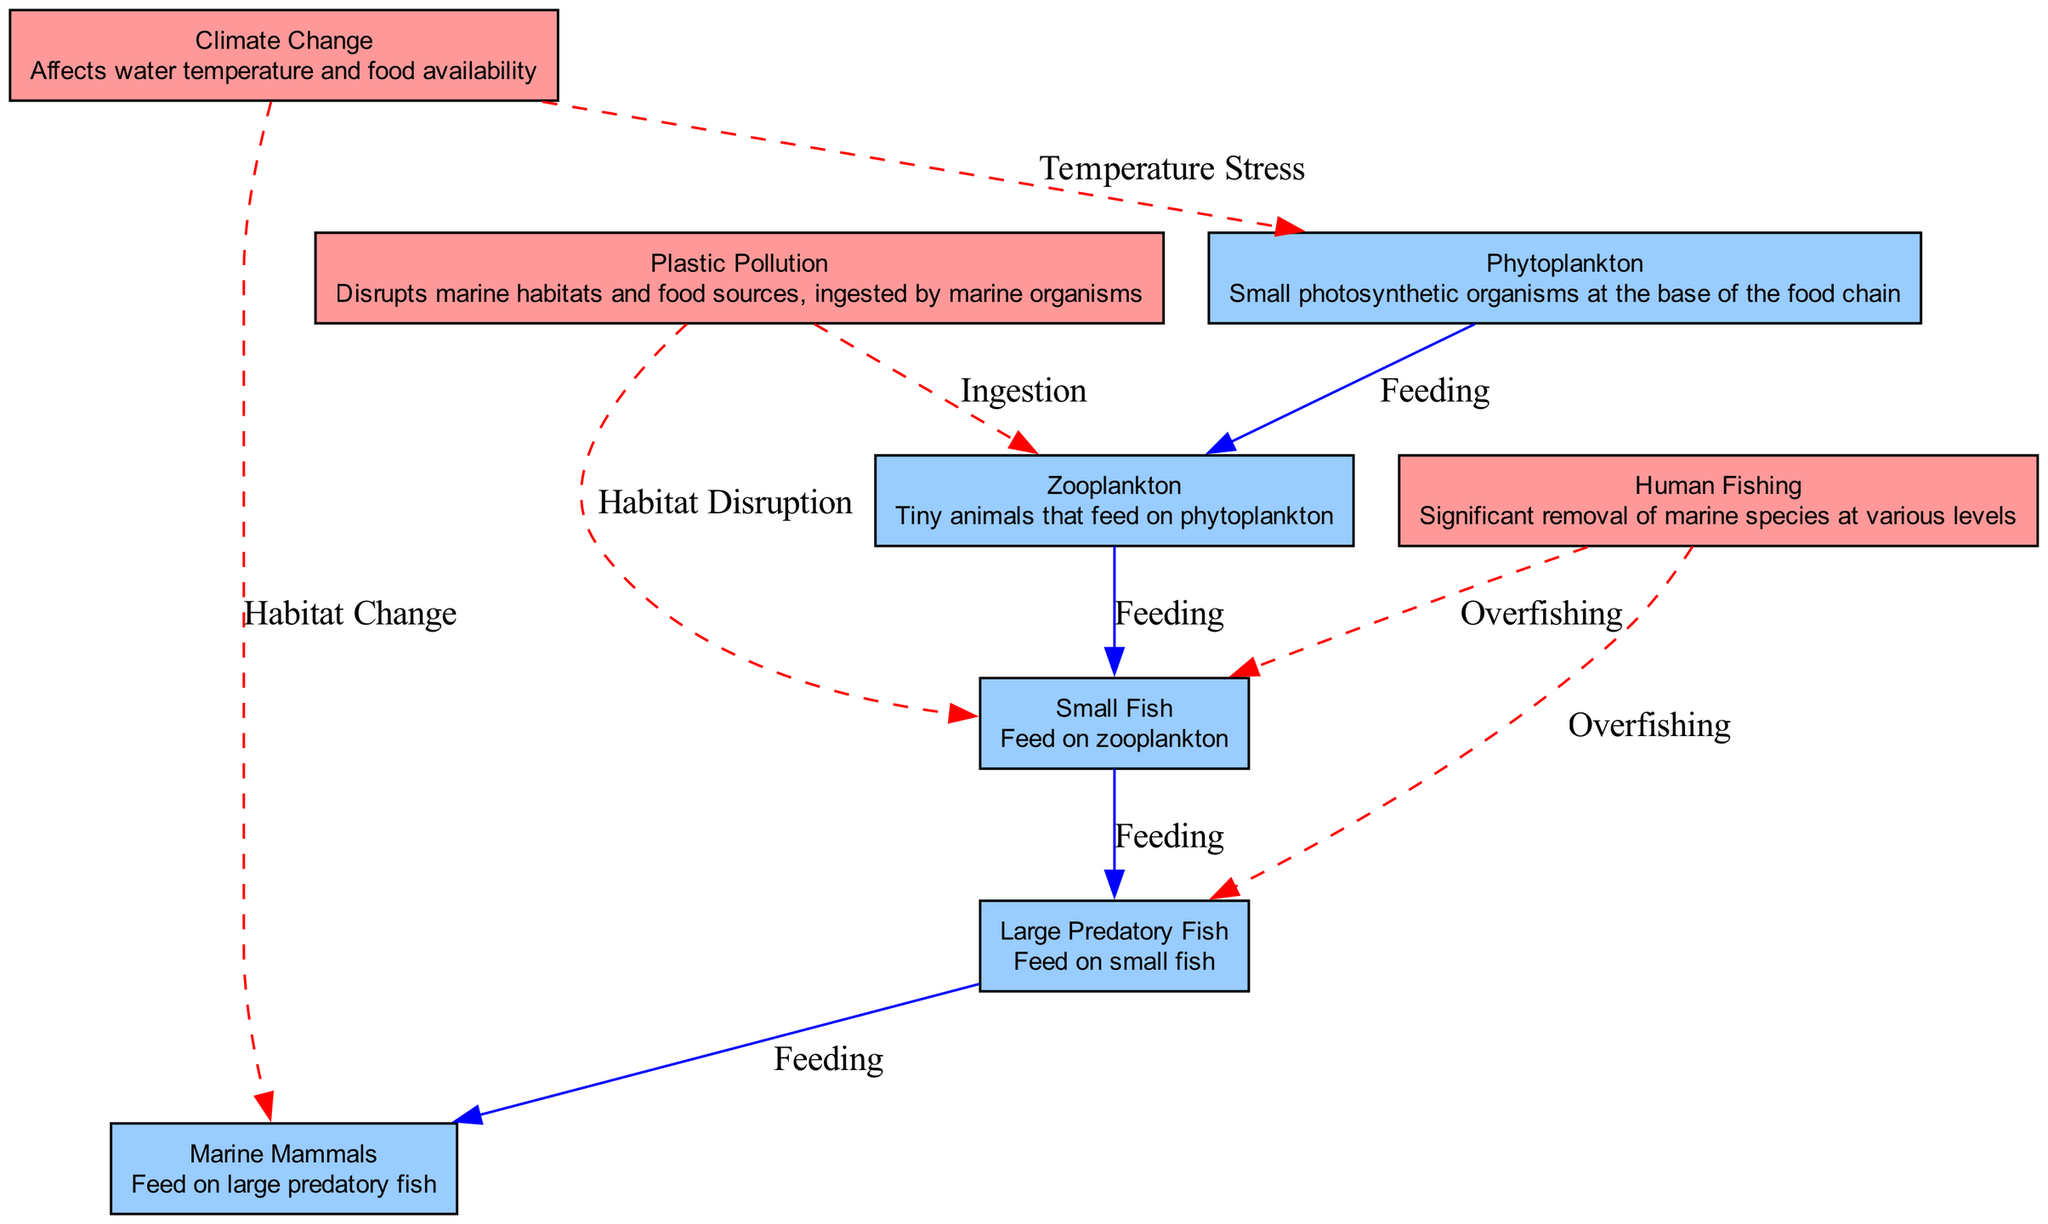What is at the base of the food chain? The base of the food chain is represented by the node labeled "Phytoplankton," which is the first organism in the marine food chain.
Answer: Phytoplankton How many nodes are present in the diagram? To determine the number of nodes, we can count the distinct entities listed in the data under the "nodes" key. There are a total of six marine organisms and three human impact factors, making a total of six nodes.
Answer: 8 Which organism feeds on zooplankton? From the diagram, it shows that "Small Fish" is the organism that directly consumes zooplankton, indicated by the directed edge labeled "Feeding."
Answer: Small Fish What type of pollution affects zooplankton? According to the diagram, the node "Plastic Pollution" has a direct edge labeled "Ingestion" leading to the zooplankton, indicating the specific type of pollution that affects them.
Answer: Plastic Pollution What impact does climate change have on marine mammals? The diagram shows an edge labeled "Habitat Change" that connects "Climate Change" to "Marine Mammals," indicating a direct impact of climate change on their habitat availability.
Answer: Habitat Change If human fishing targets small fish, what will be the probable effect on large predatory fish? The diagram indicates an "Overfishing" relationship, where human fishing removes small fish from the chain. Since large predatory fish feed on small fish, this will likely affect their availability. As a result, large predatory fish populations may decrease due to the reduced food supply.
Answer: Decrease Which node has a dashed edge connecting to small fish? In the diagram, there is a dashed edge labeled "Habitat Disruption" connecting "Plastic Pollution" to "Small Fish." Such lines typically suggest a negative impact, indicating that habitat disruption leads to adverse effects on small fish.
Answer: Plastic Pollution How does phytoplankton respond to climate change? The diagram shows that climate change leads to "Temperature Stress" on phytoplankton, indicating that changes in climate impact this primary producer at the base of the food chain.
Answer: Temperature Stress 